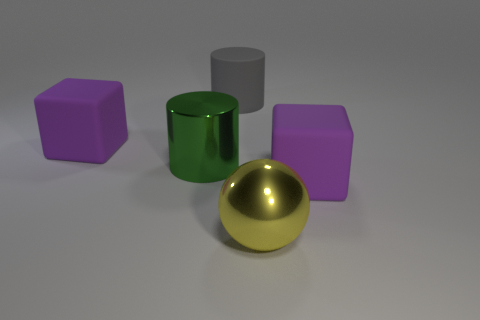There is a yellow object that is the same size as the green shiny cylinder; what is it made of?
Make the answer very short. Metal. Is there a matte block of the same size as the matte cylinder?
Provide a succinct answer. Yes. What color is the shiny thing left of the gray matte cylinder?
Your response must be concise. Green. There is a block that is to the right of the yellow shiny thing; is there a big purple matte thing in front of it?
Your answer should be very brief. No. What number of other objects are there of the same color as the large metal sphere?
Keep it short and to the point. 0. What size is the purple rubber block that is behind the big thing on the right side of the large metal ball?
Keep it short and to the point. Large. The big thing that is both behind the big metallic ball and to the right of the large gray rubber object is made of what material?
Provide a succinct answer. Rubber. What color is the matte cylinder?
Your answer should be compact. Gray. What is the shape of the shiny object left of the big yellow thing?
Ensure brevity in your answer.  Cylinder. Are there any green metal objects that are behind the big rubber block in front of the large purple block on the left side of the gray cylinder?
Keep it short and to the point. Yes. 